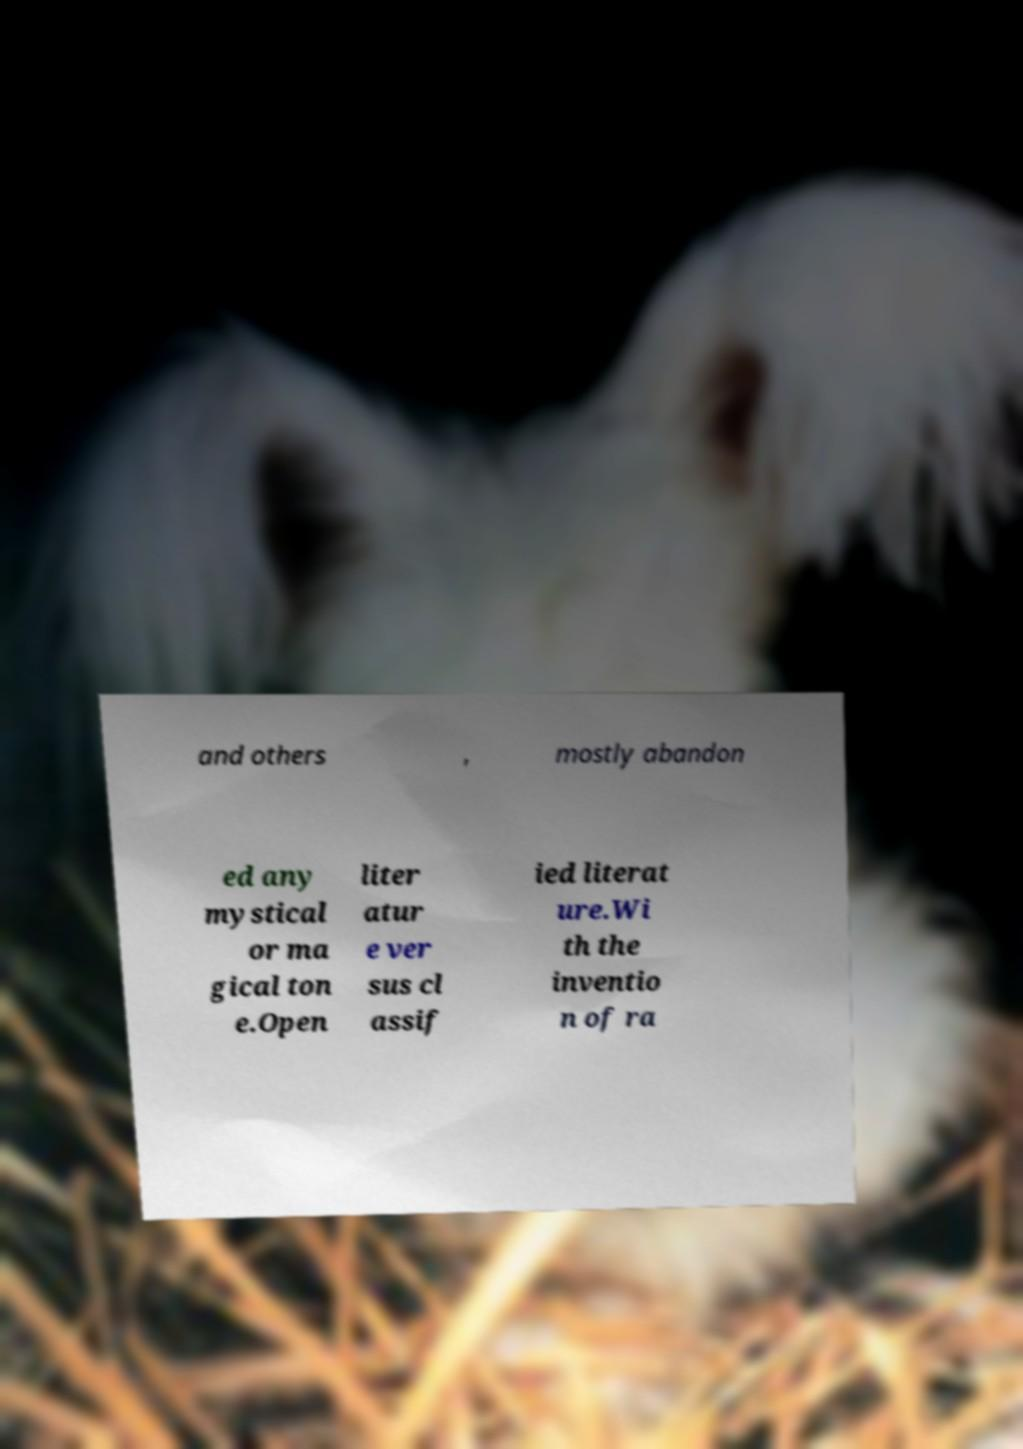Can you read and provide the text displayed in the image?This photo seems to have some interesting text. Can you extract and type it out for me? and others , mostly abandon ed any mystical or ma gical ton e.Open liter atur e ver sus cl assif ied literat ure.Wi th the inventio n of ra 